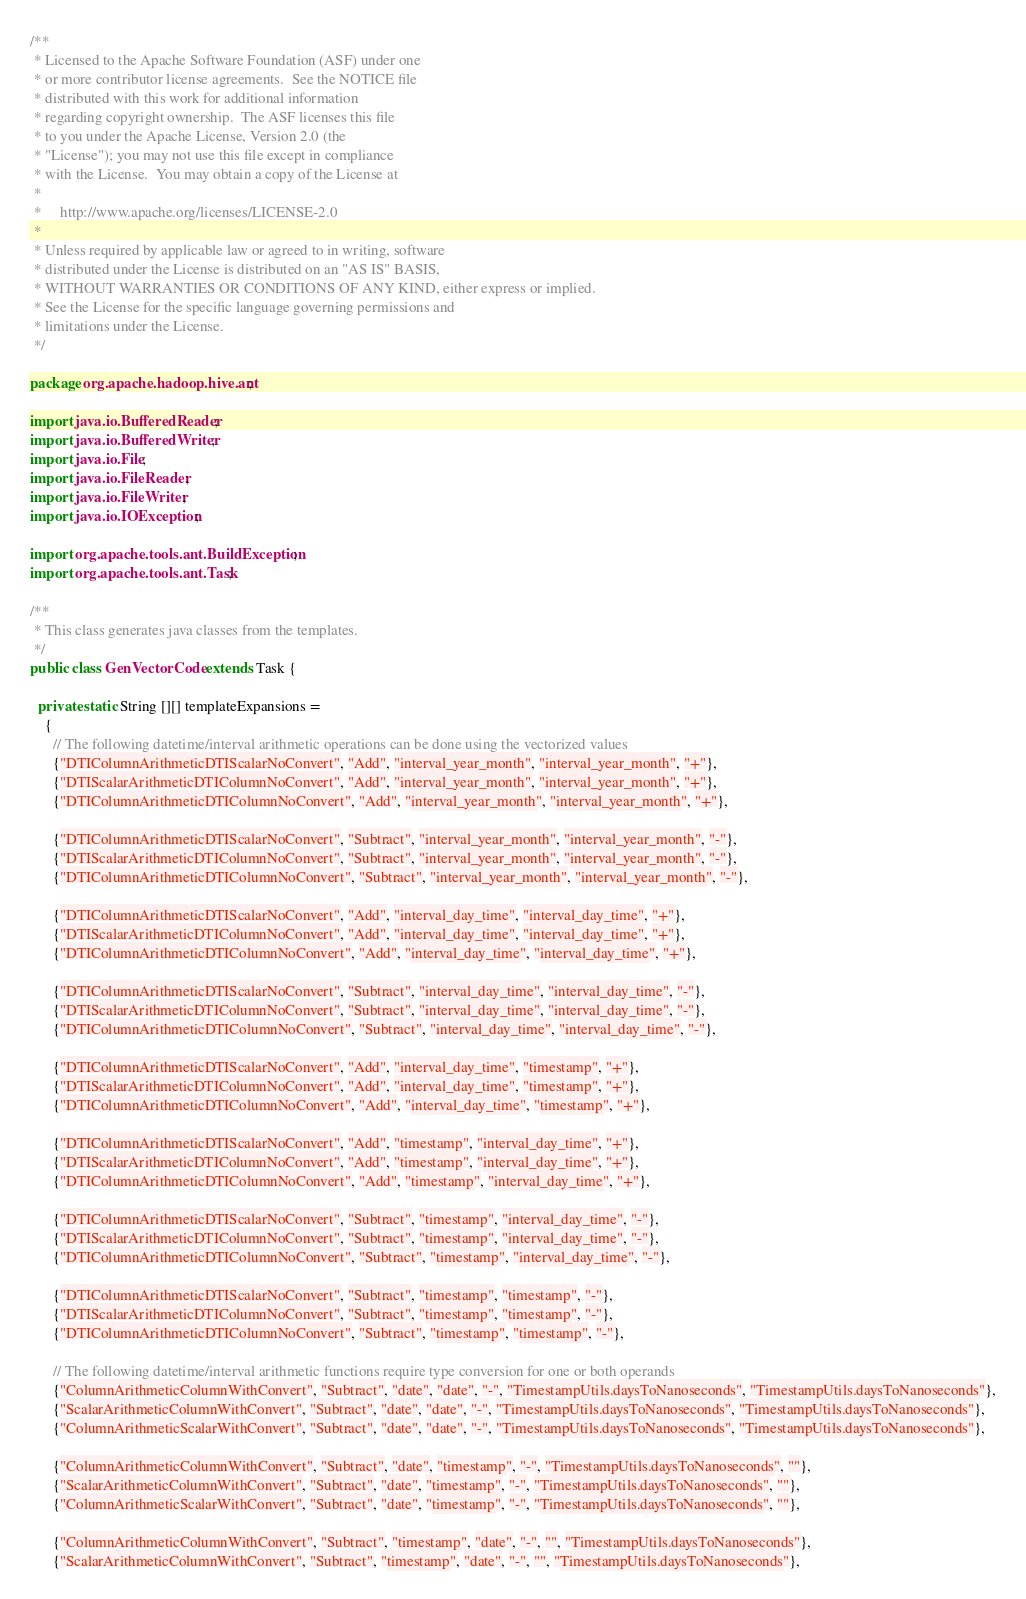Convert code to text. <code><loc_0><loc_0><loc_500><loc_500><_Java_>/**
 * Licensed to the Apache Software Foundation (ASF) under one
 * or more contributor license agreements.  See the NOTICE file
 * distributed with this work for additional information
 * regarding copyright ownership.  The ASF licenses this file
 * to you under the Apache License, Version 2.0 (the
 * "License"); you may not use this file except in compliance
 * with the License.  You may obtain a copy of the License at
 *
 *     http://www.apache.org/licenses/LICENSE-2.0
 *
 * Unless required by applicable law or agreed to in writing, software
 * distributed under the License is distributed on an "AS IS" BASIS,
 * WITHOUT WARRANTIES OR CONDITIONS OF ANY KIND, either express or implied.
 * See the License for the specific language governing permissions and
 * limitations under the License.
 */

package org.apache.hadoop.hive.ant;

import java.io.BufferedReader;
import java.io.BufferedWriter;
import java.io.File;
import java.io.FileReader;
import java.io.FileWriter;
import java.io.IOException;

import org.apache.tools.ant.BuildException;
import org.apache.tools.ant.Task;

/**
 * This class generates java classes from the templates.
 */
public class GenVectorCode extends Task {

  private static String [][] templateExpansions =
    {
      // The following datetime/interval arithmetic operations can be done using the vectorized values
      {"DTIColumnArithmeticDTIScalarNoConvert", "Add", "interval_year_month", "interval_year_month", "+"},
      {"DTIScalarArithmeticDTIColumnNoConvert", "Add", "interval_year_month", "interval_year_month", "+"},
      {"DTIColumnArithmeticDTIColumnNoConvert", "Add", "interval_year_month", "interval_year_month", "+"},

      {"DTIColumnArithmeticDTIScalarNoConvert", "Subtract", "interval_year_month", "interval_year_month", "-"},
      {"DTIScalarArithmeticDTIColumnNoConvert", "Subtract", "interval_year_month", "interval_year_month", "-"},
      {"DTIColumnArithmeticDTIColumnNoConvert", "Subtract", "interval_year_month", "interval_year_month", "-"},

      {"DTIColumnArithmeticDTIScalarNoConvert", "Add", "interval_day_time", "interval_day_time", "+"},
      {"DTIScalarArithmeticDTIColumnNoConvert", "Add", "interval_day_time", "interval_day_time", "+"},
      {"DTIColumnArithmeticDTIColumnNoConvert", "Add", "interval_day_time", "interval_day_time", "+"},

      {"DTIColumnArithmeticDTIScalarNoConvert", "Subtract", "interval_day_time", "interval_day_time", "-"},
      {"DTIScalarArithmeticDTIColumnNoConvert", "Subtract", "interval_day_time", "interval_day_time", "-"},
      {"DTIColumnArithmeticDTIColumnNoConvert", "Subtract", "interval_day_time", "interval_day_time", "-"},

      {"DTIColumnArithmeticDTIScalarNoConvert", "Add", "interval_day_time", "timestamp", "+"},
      {"DTIScalarArithmeticDTIColumnNoConvert", "Add", "interval_day_time", "timestamp", "+"},
      {"DTIColumnArithmeticDTIColumnNoConvert", "Add", "interval_day_time", "timestamp", "+"},

      {"DTIColumnArithmeticDTIScalarNoConvert", "Add", "timestamp", "interval_day_time", "+"},
      {"DTIScalarArithmeticDTIColumnNoConvert", "Add", "timestamp", "interval_day_time", "+"},
      {"DTIColumnArithmeticDTIColumnNoConvert", "Add", "timestamp", "interval_day_time", "+"},

      {"DTIColumnArithmeticDTIScalarNoConvert", "Subtract", "timestamp", "interval_day_time", "-"},
      {"DTIScalarArithmeticDTIColumnNoConvert", "Subtract", "timestamp", "interval_day_time", "-"},
      {"DTIColumnArithmeticDTIColumnNoConvert", "Subtract", "timestamp", "interval_day_time", "-"},

      {"DTIColumnArithmeticDTIScalarNoConvert", "Subtract", "timestamp", "timestamp", "-"},
      {"DTIScalarArithmeticDTIColumnNoConvert", "Subtract", "timestamp", "timestamp", "-"},
      {"DTIColumnArithmeticDTIColumnNoConvert", "Subtract", "timestamp", "timestamp", "-"},

      // The following datetime/interval arithmetic functions require type conversion for one or both operands
      {"ColumnArithmeticColumnWithConvert", "Subtract", "date", "date", "-", "TimestampUtils.daysToNanoseconds", "TimestampUtils.daysToNanoseconds"},
      {"ScalarArithmeticColumnWithConvert", "Subtract", "date", "date", "-", "TimestampUtils.daysToNanoseconds", "TimestampUtils.daysToNanoseconds"},
      {"ColumnArithmeticScalarWithConvert", "Subtract", "date", "date", "-", "TimestampUtils.daysToNanoseconds", "TimestampUtils.daysToNanoseconds"},

      {"ColumnArithmeticColumnWithConvert", "Subtract", "date", "timestamp", "-", "TimestampUtils.daysToNanoseconds", ""},
      {"ScalarArithmeticColumnWithConvert", "Subtract", "date", "timestamp", "-", "TimestampUtils.daysToNanoseconds", ""},
      {"ColumnArithmeticScalarWithConvert", "Subtract", "date", "timestamp", "-", "TimestampUtils.daysToNanoseconds", ""},

      {"ColumnArithmeticColumnWithConvert", "Subtract", "timestamp", "date", "-", "", "TimestampUtils.daysToNanoseconds"},
      {"ScalarArithmeticColumnWithConvert", "Subtract", "timestamp", "date", "-", "", "TimestampUtils.daysToNanoseconds"},</code> 